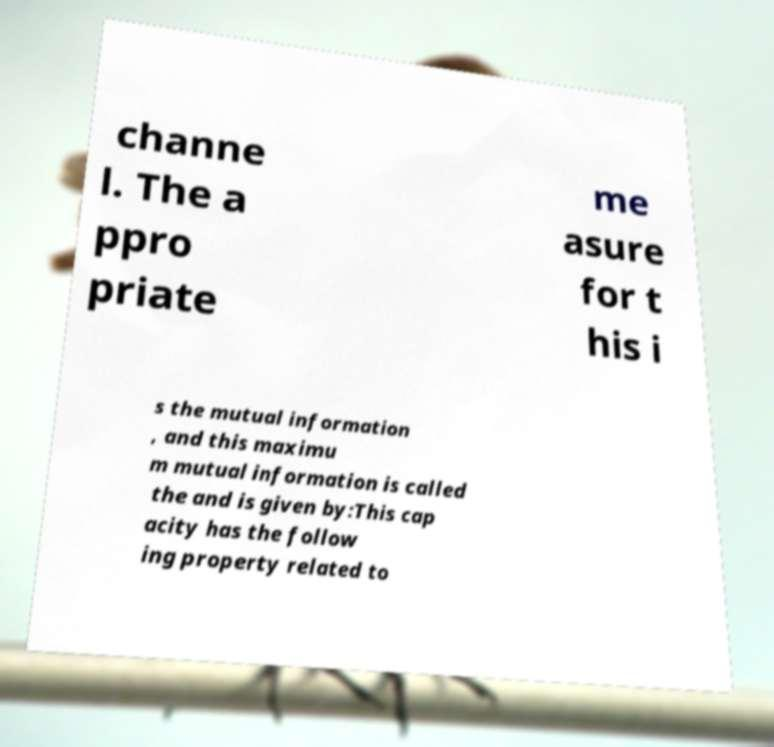There's text embedded in this image that I need extracted. Can you transcribe it verbatim? channe l. The a ppro priate me asure for t his i s the mutual information , and this maximu m mutual information is called the and is given by:This cap acity has the follow ing property related to 